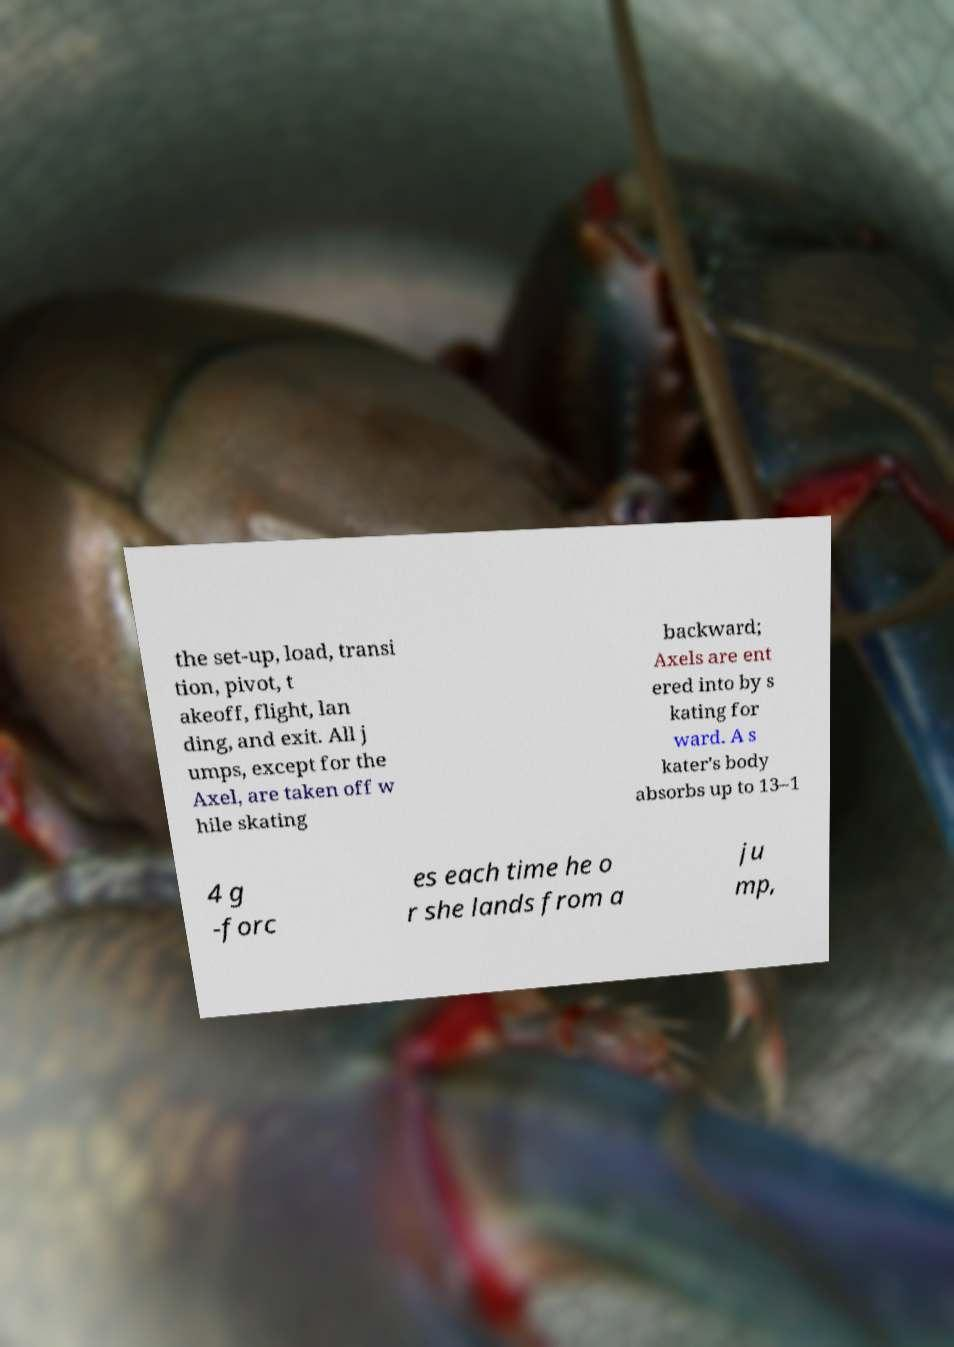There's text embedded in this image that I need extracted. Can you transcribe it verbatim? the set-up, load, transi tion, pivot, t akeoff, flight, lan ding, and exit. All j umps, except for the Axel, are taken off w hile skating backward; Axels are ent ered into by s kating for ward. A s kater's body absorbs up to 13–1 4 g -forc es each time he o r she lands from a ju mp, 